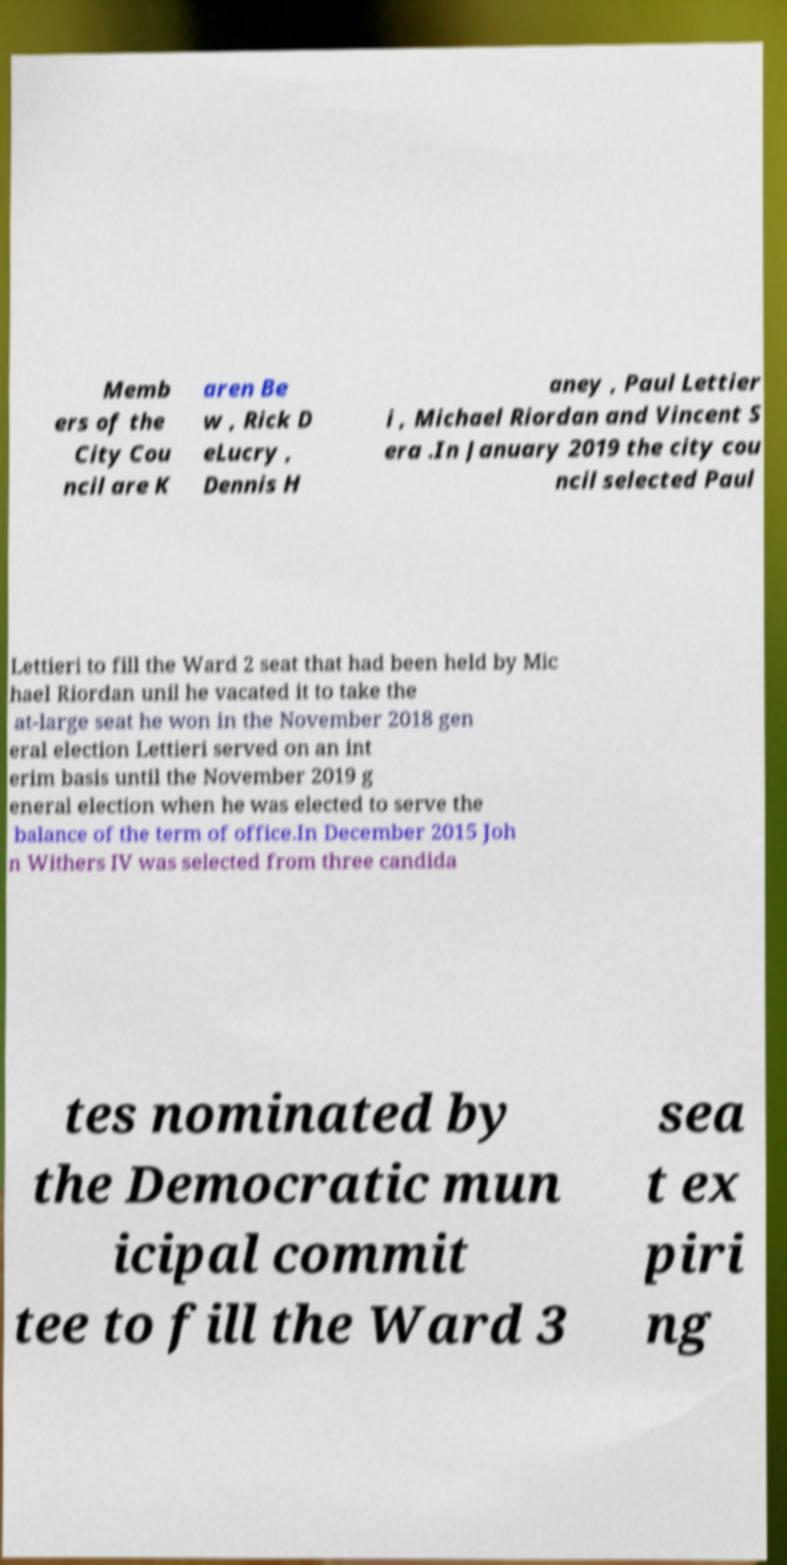For documentation purposes, I need the text within this image transcribed. Could you provide that? Memb ers of the City Cou ncil are K aren Be w , Rick D eLucry , Dennis H aney , Paul Lettier i , Michael Riordan and Vincent S era .In January 2019 the city cou ncil selected Paul Lettieri to fill the Ward 2 seat that had been held by Mic hael Riordan unil he vacated it to take the at-large seat he won in the November 2018 gen eral election Lettieri served on an int erim basis until the November 2019 g eneral election when he was elected to serve the balance of the term of office.In December 2015 Joh n Withers IV was selected from three candida tes nominated by the Democratic mun icipal commit tee to fill the Ward 3 sea t ex piri ng 